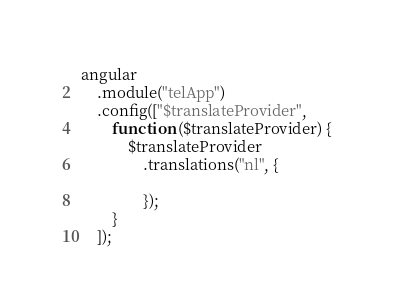Convert code to text. <code><loc_0><loc_0><loc_500><loc_500><_JavaScript_>angular
    .module("telApp")
    .config(["$translateProvider",
        function ($translateProvider) {
            $translateProvider
                .translations("nl", {

                });
        }
    ]);
</code> 